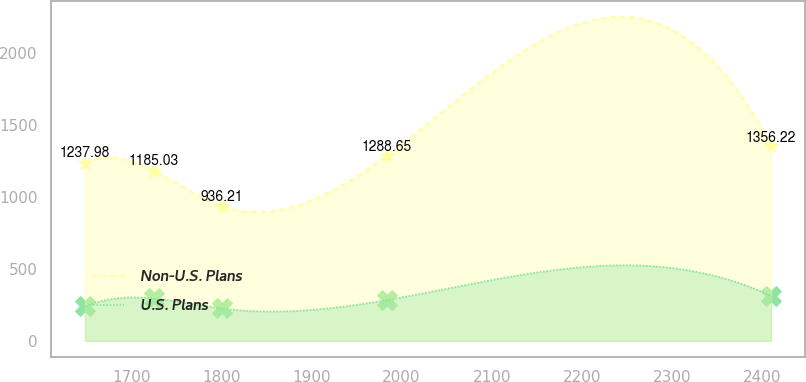<chart> <loc_0><loc_0><loc_500><loc_500><line_chart><ecel><fcel>Non-U.S. Plans<fcel>U.S. Plans<nl><fcel>1648.5<fcel>1237.98<fcel>240.36<nl><fcel>1724.67<fcel>1185.03<fcel>295.6<nl><fcel>1800.84<fcel>936.21<fcel>225.24<nl><fcel>1983.52<fcel>1288.65<fcel>284.53<nl><fcel>2410.2<fcel>1356.22<fcel>313.45<nl></chart> 